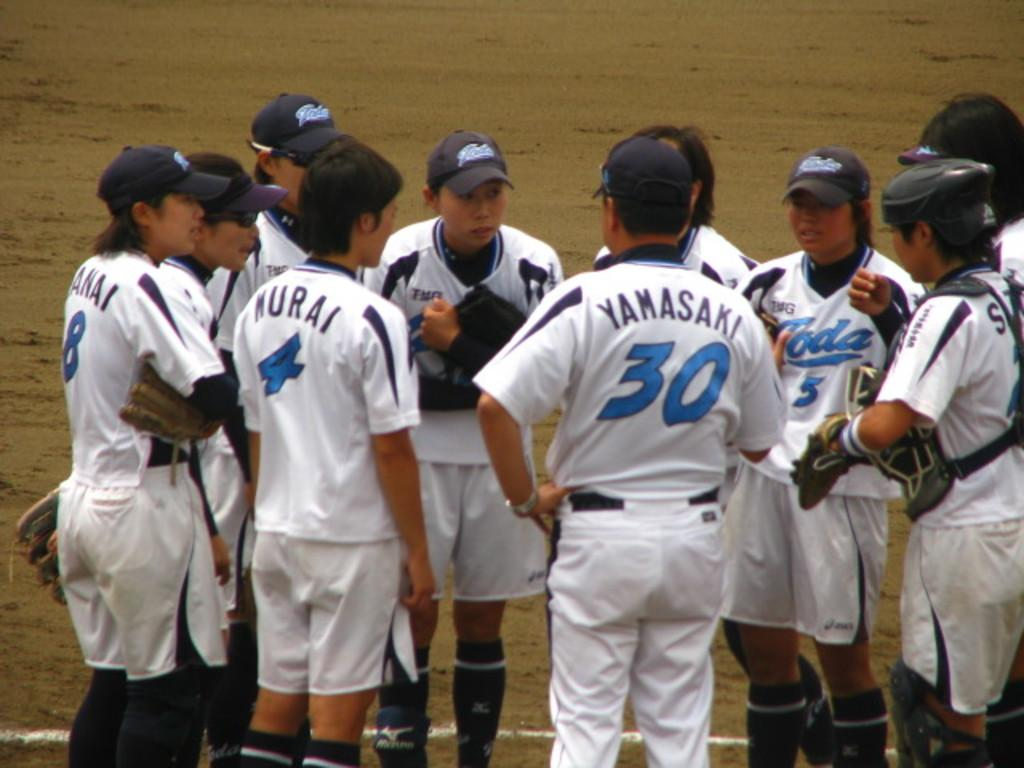<image>
Give a short and clear explanation of the subsequent image. baseball players like Yamasaki 30 and Murai 4 huddle around each other 